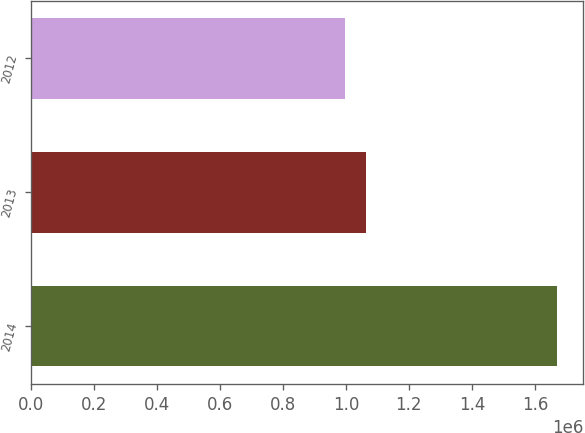Convert chart. <chart><loc_0><loc_0><loc_500><loc_500><bar_chart><fcel>2014<fcel>2013<fcel>2012<nl><fcel>1.67057e+06<fcel>1.06361e+06<fcel>996168<nl></chart> 